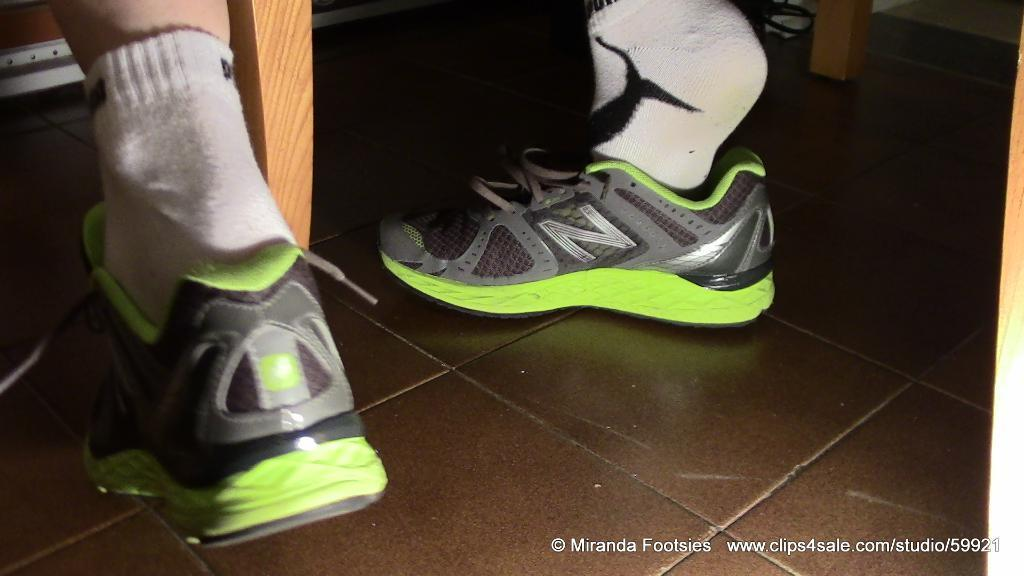What part of the body is visible in the image in the image? There is a human leg in the image. What type of clothing is covering the person's feet? The person is wearing socks and shoes. What type of surface is visible beneath the leg? There is a floor visible in the image. What material is the wooden object made of? The wooden object in the image is made of wood. Is there any text or logo visible in the image? Yes, there is a watermark in the image. What type of suit is the person wearing in the image? There is no suit visible in the image; only a leg, socks, and shoes are present. Are there any friends visible in the image? There is no indication of friends or any other people in the image, as it only shows a leg, socks, and shoes. 